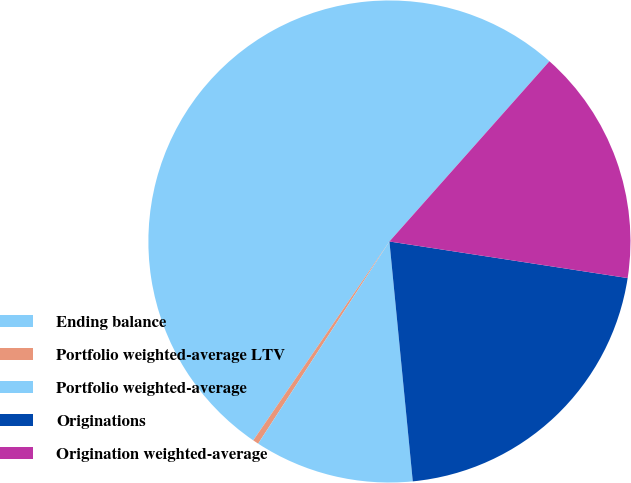Convert chart to OTSL. <chart><loc_0><loc_0><loc_500><loc_500><pie_chart><fcel>Ending balance<fcel>Portfolio weighted-average LTV<fcel>Portfolio weighted-average<fcel>Originations<fcel>Origination weighted-average<nl><fcel>52.0%<fcel>0.39%<fcel>10.71%<fcel>21.03%<fcel>15.87%<nl></chart> 